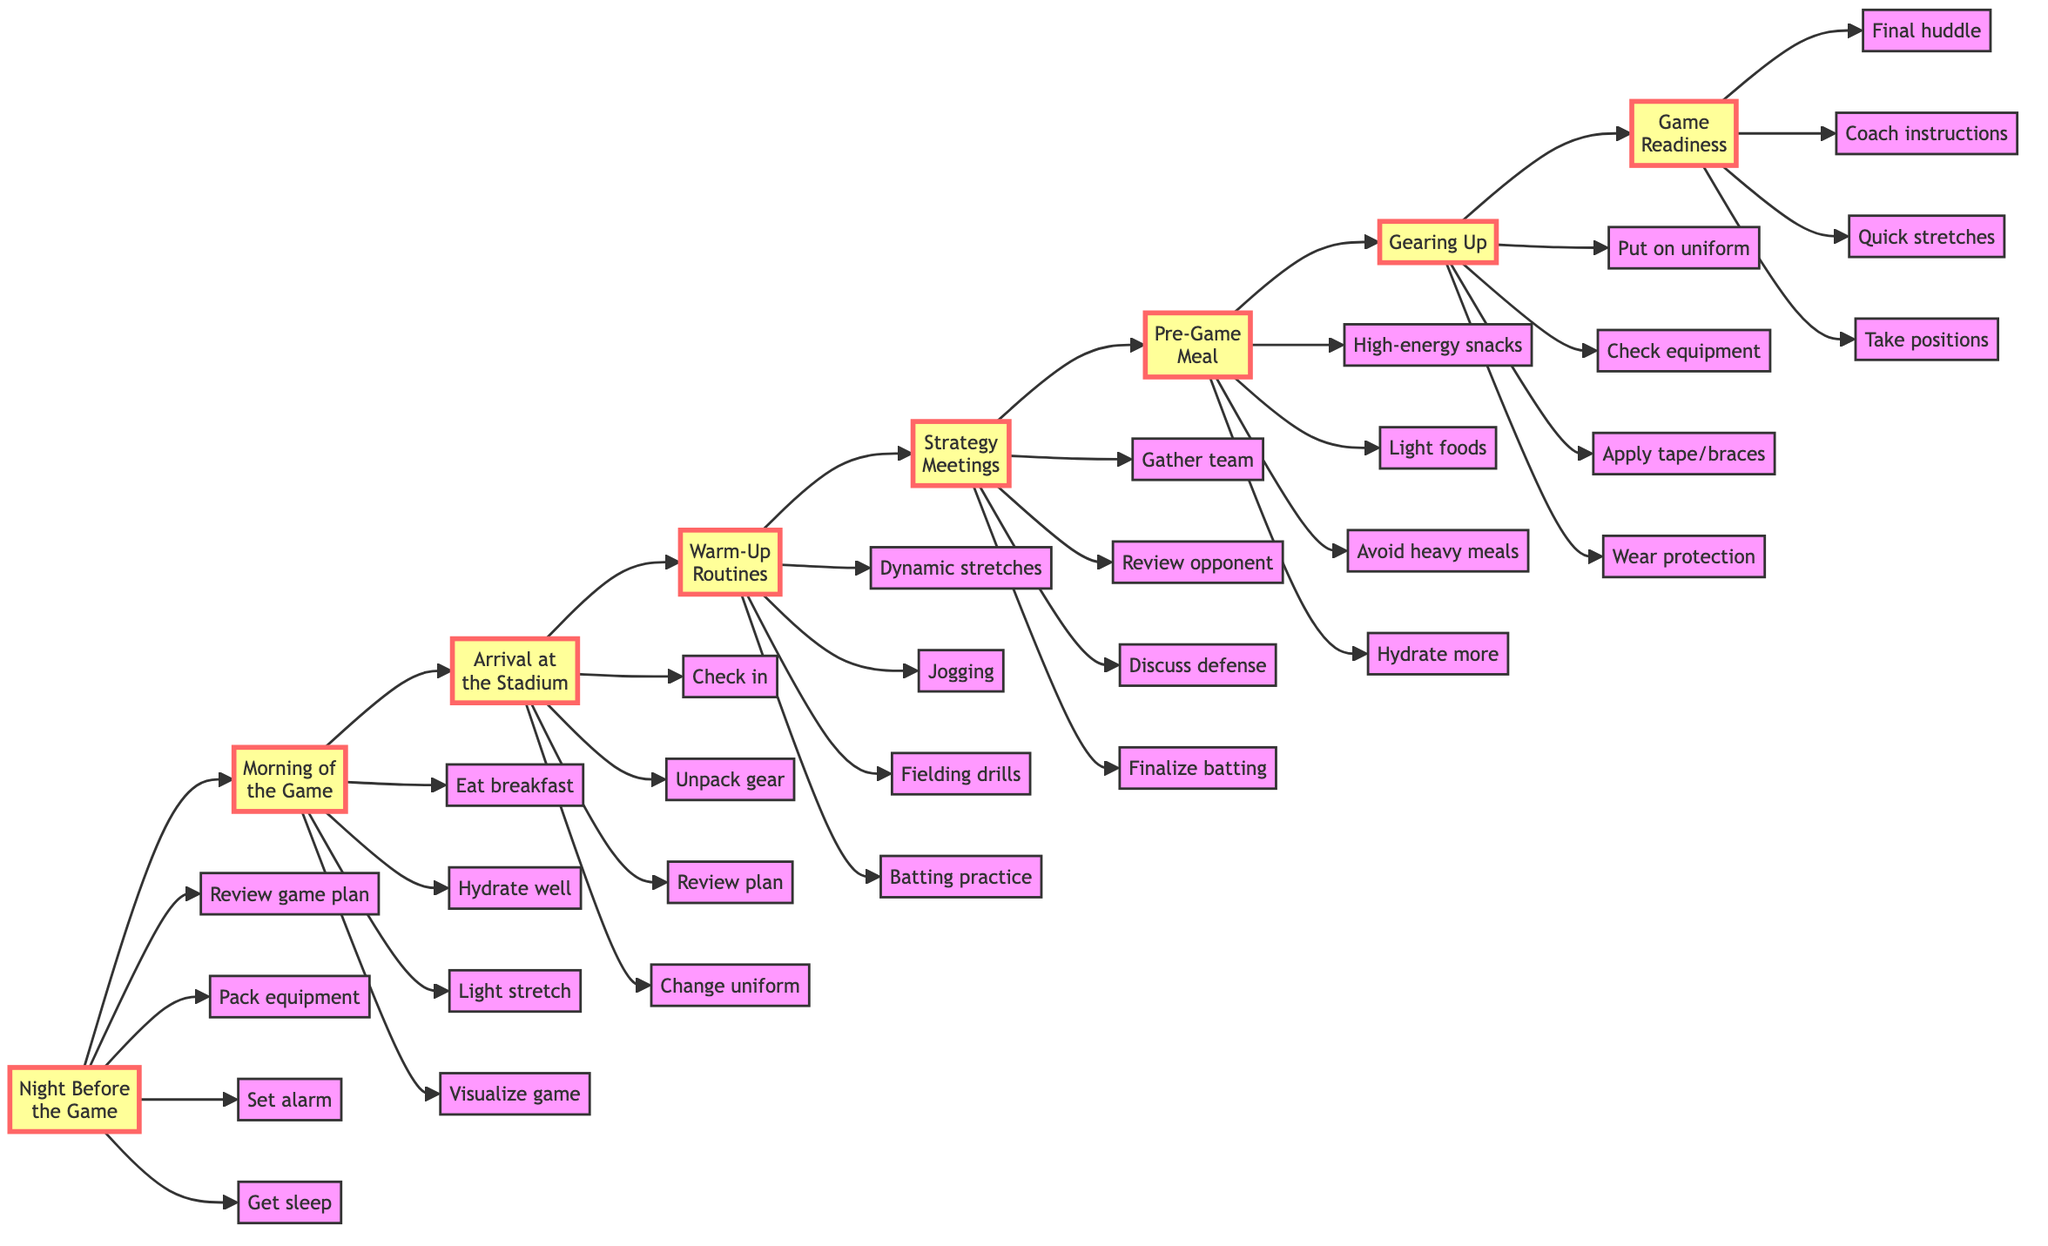What is the first step in the pre-game preparation checklist? The first step listed in the diagram is "Review game plan and personal notes," found under "Night Before the Game."
Answer: Review game plan and personal notes How many steps are there in the "Arrival at the Stadium"? The "Arrival at the Stadium" node has four steps listed below it: "Check in with coach and team," "Unpack gear and arrange locker," "Review game plan with teammates," and "Change into practice uniform." Therefore, there are a total of 4 steps.
Answer: 4 Which section follows "Warm-Up Routines" in the flowchart? In the flowchart, "Strategy Meetings" comes directly after "Warm-Up Routines," indicating the next stage of preparation.
Answer: Strategy Meetings What is included in the "Pre-Game Meal" steps? The "Pre-Game Meal" section includes: "Consume high-energy snacks: bananas, protein bars," "Prefer light, easily digestible foods," "Avoid heavy or greasy meals," and "Hydrate continually." This indicates a focus on nutrition before the game.
Answer: Consume high-energy snacks: bananas, protein bars What do you do right after "Gearing Up"? The step that follows "Gearing Up" is "Game Readiness," illustrating the transition from personal preparation to team readiness for the game.
Answer: Game Readiness How many total sections are represented in the flowchart? The flowchart contains eight sections: "Night Before the Game," "Morning of the Game," "Arrival at the Stadium," "Warm-Up Routines," "Strategy Meetings," "Pre-Game Meal," "Gearing Up," and "Game Readiness." Thus, the total number of sections is 8.
Answer: 8 What is the last activity mentioned before heading to the field? The last activity listed before heading to the assigned field positions is "Perform quick, last-minute stretches," indicating a final physical preparation step.
Answer: Perform quick, last-minute stretches What is one reason to avoid heavy meals before the game? One reason specified in the "Pre-Game Meal" checklist is to prefer light, easily digestible foods to ensure optimal performance and comfort during the game.
Answer: Avoid heavy or greasy meals 